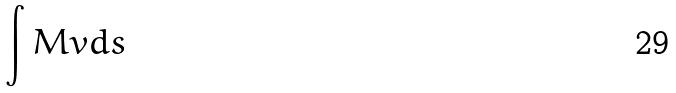<formula> <loc_0><loc_0><loc_500><loc_500>\int M v d s</formula> 